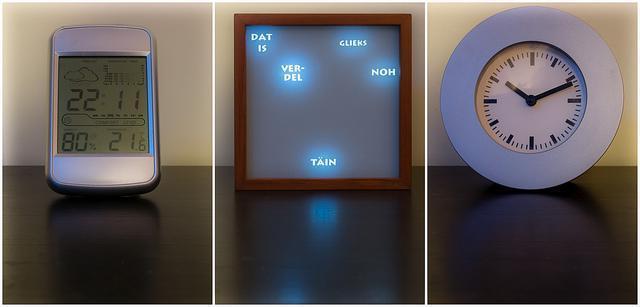How many clocks are there?
Give a very brief answer. 2. 